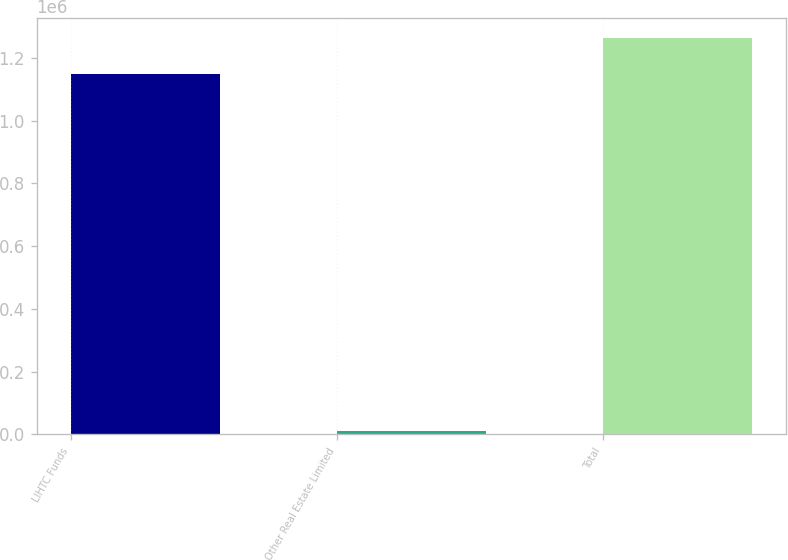Convert chart to OTSL. <chart><loc_0><loc_0><loc_500><loc_500><bar_chart><fcel>LIHTC Funds<fcel>Other Real Estate Limited<fcel>Total<nl><fcel>1.14862e+06<fcel>11003<fcel>1.26348e+06<nl></chart> 